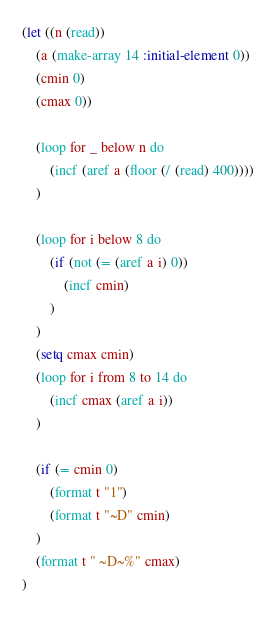<code> <loc_0><loc_0><loc_500><loc_500><_Lisp_>(let ((n (read))
    (a (make-array 14 :initial-element 0))
    (cmin 0)
    (cmax 0))

    (loop for _ below n do
        (incf (aref a (floor (/ (read) 400))))
    )

    (loop for i below 8 do
        (if (not (= (aref a i) 0))
            (incf cmin)
        )
    )
    (setq cmax cmin)
    (loop for i from 8 to 14 do
        (incf cmax (aref a i))
    )

    (if (= cmin 0)
        (format t "1")
        (format t "~D" cmin)
    )
    (format t " ~D~%" cmax)
)</code> 